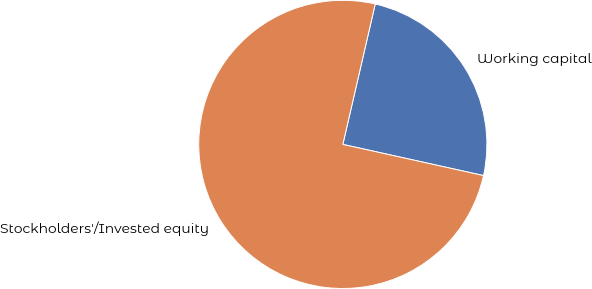<chart> <loc_0><loc_0><loc_500><loc_500><pie_chart><fcel>Working capital<fcel>Stockholders'/Invested equity<nl><fcel>24.86%<fcel>75.14%<nl></chart> 